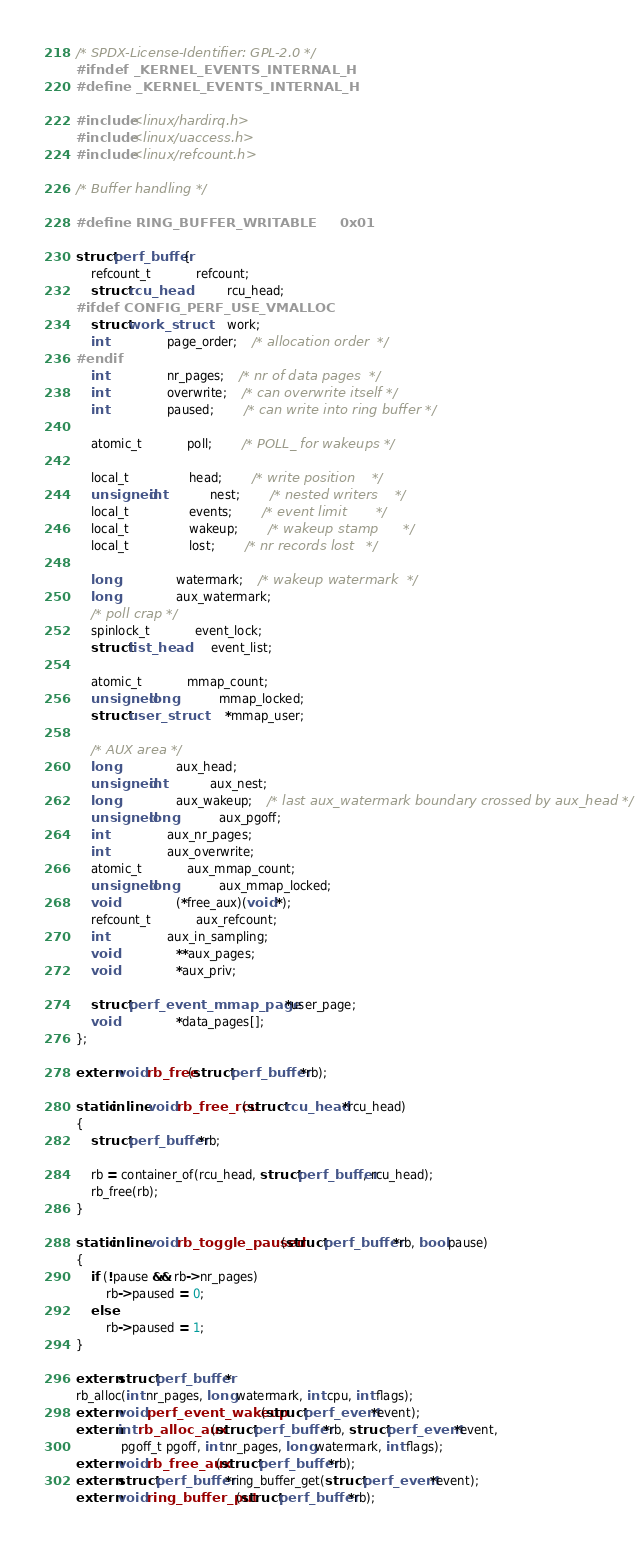<code> <loc_0><loc_0><loc_500><loc_500><_C_>/* SPDX-License-Identifier: GPL-2.0 */
#ifndef _KERNEL_EVENTS_INTERNAL_H
#define _KERNEL_EVENTS_INTERNAL_H

#include <linux/hardirq.h>
#include <linux/uaccess.h>
#include <linux/refcount.h>

/* Buffer handling */

#define RING_BUFFER_WRITABLE		0x01

struct perf_buffer {
	refcount_t			refcount;
	struct rcu_head			rcu_head;
#ifdef CONFIG_PERF_USE_VMALLOC
	struct work_struct		work;
	int				page_order;	/* allocation order  */
#endif
	int				nr_pages;	/* nr of data pages  */
	int				overwrite;	/* can overwrite itself */
	int				paused;		/* can write into ring buffer */

	atomic_t			poll;		/* POLL_ for wakeups */

	local_t				head;		/* write position    */
	unsigned int			nest;		/* nested writers    */
	local_t				events;		/* event limit       */
	local_t				wakeup;		/* wakeup stamp      */
	local_t				lost;		/* nr records lost   */

	long				watermark;	/* wakeup watermark  */
	long				aux_watermark;
	/* poll crap */
	spinlock_t			event_lock;
	struct list_head		event_list;

	atomic_t			mmap_count;
	unsigned long			mmap_locked;
	struct user_struct		*mmap_user;

	/* AUX area */
	long				aux_head;
	unsigned int			aux_nest;
	long				aux_wakeup;	/* last aux_watermark boundary crossed by aux_head */
	unsigned long			aux_pgoff;
	int				aux_nr_pages;
	int				aux_overwrite;
	atomic_t			aux_mmap_count;
	unsigned long			aux_mmap_locked;
	void				(*free_aux)(void *);
	refcount_t			aux_refcount;
	int				aux_in_sampling;
	void				**aux_pages;
	void				*aux_priv;

	struct perf_event_mmap_page	*user_page;
	void				*data_pages[];
};

extern void rb_free(struct perf_buffer *rb);

static inline void rb_free_rcu(struct rcu_head *rcu_head)
{
	struct perf_buffer *rb;

	rb = container_of(rcu_head, struct perf_buffer, rcu_head);
	rb_free(rb);
}

static inline void rb_toggle_paused(struct perf_buffer *rb, bool pause)
{
	if (!pause && rb->nr_pages)
		rb->paused = 0;
	else
		rb->paused = 1;
}

extern struct perf_buffer *
rb_alloc(int nr_pages, long watermark, int cpu, int flags);
extern void perf_event_wakeup(struct perf_event *event);
extern int rb_alloc_aux(struct perf_buffer *rb, struct perf_event *event,
			pgoff_t pgoff, int nr_pages, long watermark, int flags);
extern void rb_free_aux(struct perf_buffer *rb);
extern struct perf_buffer *ring_buffer_get(struct perf_event *event);
extern void ring_buffer_put(struct perf_buffer *rb);
</code> 